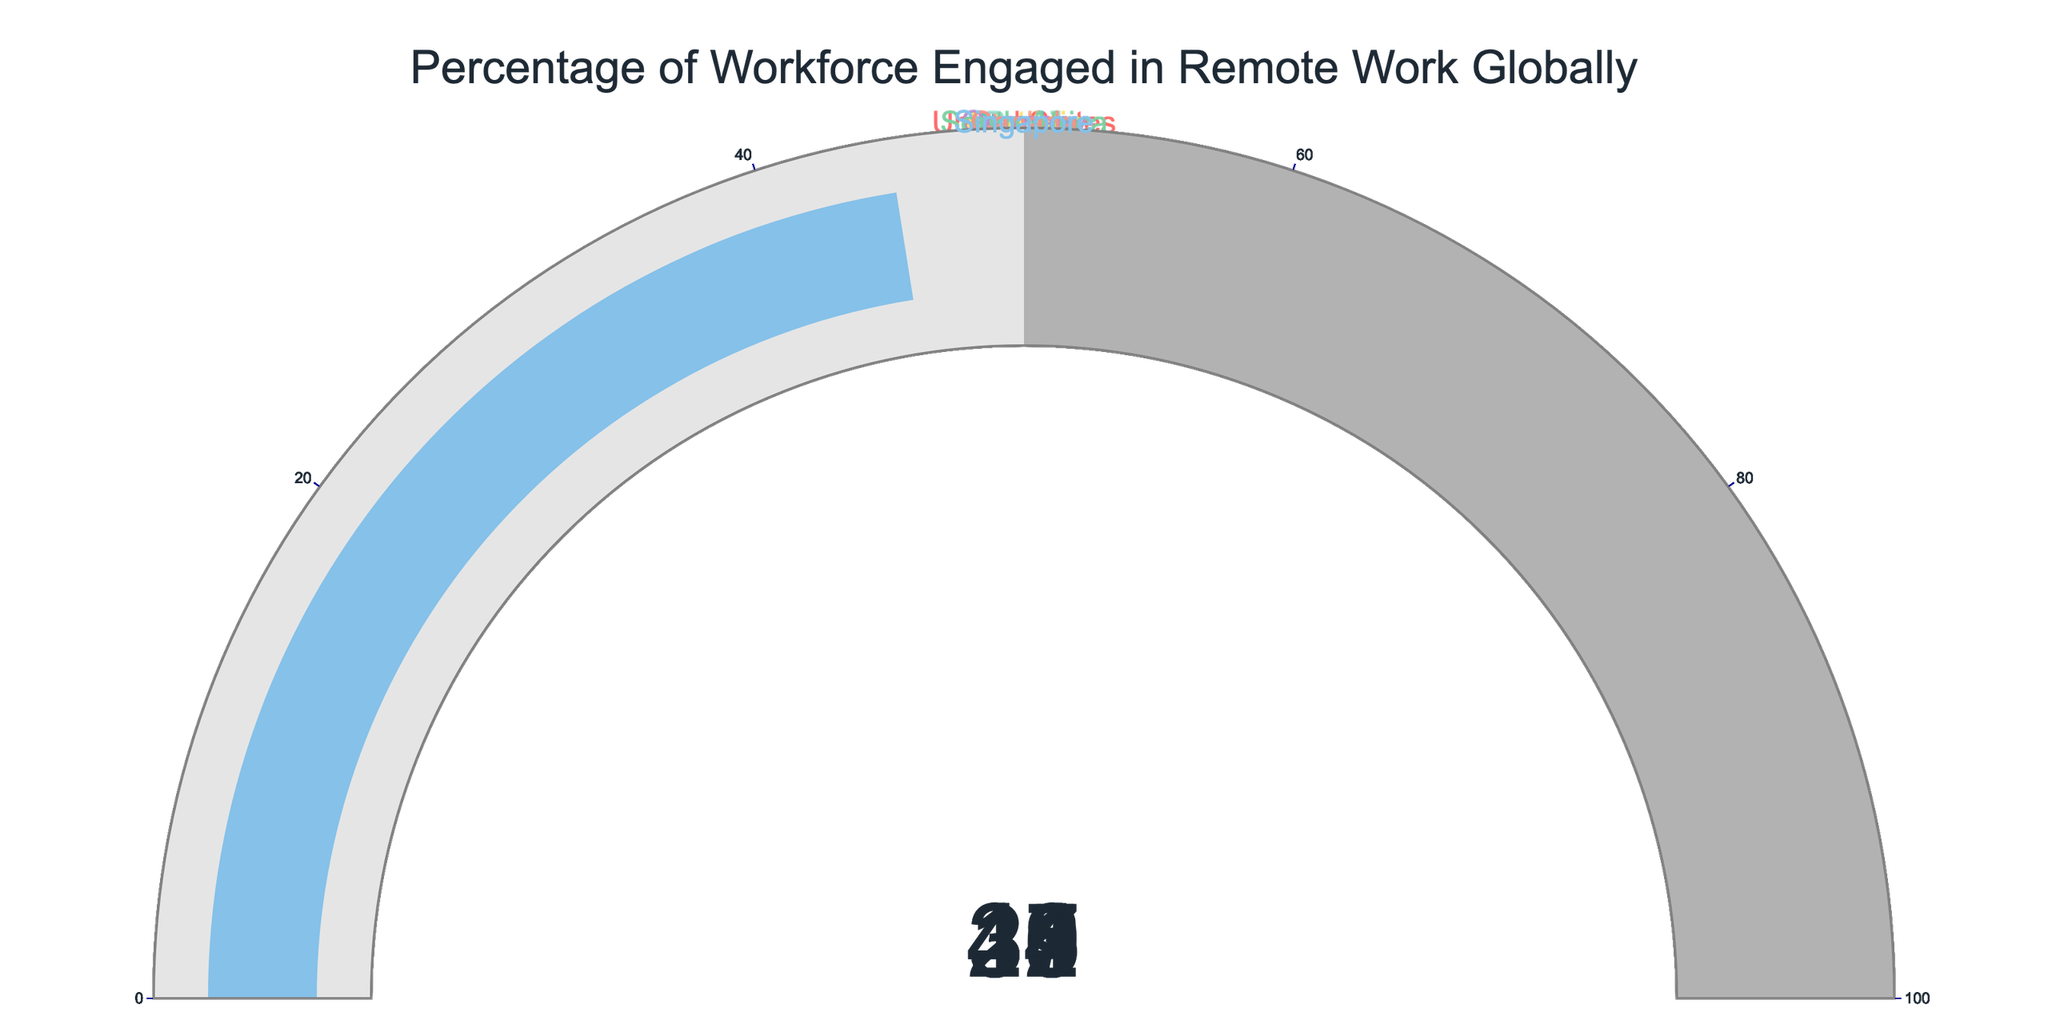What is the highest percentage of workforce engaged in remote work? The figures for each country display the percentage of the workforce engaged in remote work. The highest value among them is 45% for Singapore.
Answer: 45% What is the lowest percentage of workforce engaged in remote work? By observing the gauges, the lowest percentage is 16% which belongs to Japan.
Answer: 16% What's the average percentage of workforce engaged in remote work across all countries? Add the percentages of all countries (44 + 33 + 16 + 32 + 25 + 41 + 37 + 23 + 39 + 45) which equals 335, then divide by the number of countries, which is 10. The average is 335/10 = 33.5.
Answer: 33.5 Which countries have a remote work percentage greater than 40%? By identifying the gauges with values above 40%, we can see the United States, Australia, Canada, and Singapore have percentages greater than 40%.
Answer: United States, Australia, Canada, and Singapore What is the difference in remote work percentage between the United States and India? The percentage for the United States is 44%, and for India, it's 32%. The difference is calculated as 44 - 32 = 12%.
Answer: 12% How many countries have a remote work percentage below 30%? By counting the gauges with values below 30%, we find Japan (16%) and South Africa (23%), totaling 2 countries.
Answer: 2 What is the total percentage for the countries with the top three highest remote work rates? The top three countries by remote work percentage are Singapore (45%), United States (44%), and Australia (41%). Their total is 45 + 44 + 41 = 130.
Answer: 130 Which country has a remote work percentage closest to the average percentage (33.5%)? By comparing each gauge value to 33.5%, we see that Sweden with 33% is the closest.
Answer: Sweden Is the remote work percentage in Sweden more than that in India? By comparing the gauges for Sweden (33%) and India (32%), it is evident that Sweden's percentage is slightly more.
Answer: Yes What is the range of the remote work percentages across all countries? The highest percentage is 45% (Singapore), and the lowest is 16% (Japan). The range is calculated as 45 - 16 = 29.
Answer: 29 